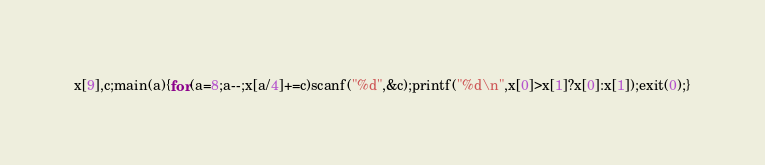<code> <loc_0><loc_0><loc_500><loc_500><_C_>x[9],c;main(a){for(a=8;a--;x[a/4]+=c)scanf("%d",&c);printf("%d\n",x[0]>x[1]?x[0]:x[1]);exit(0);}</code> 